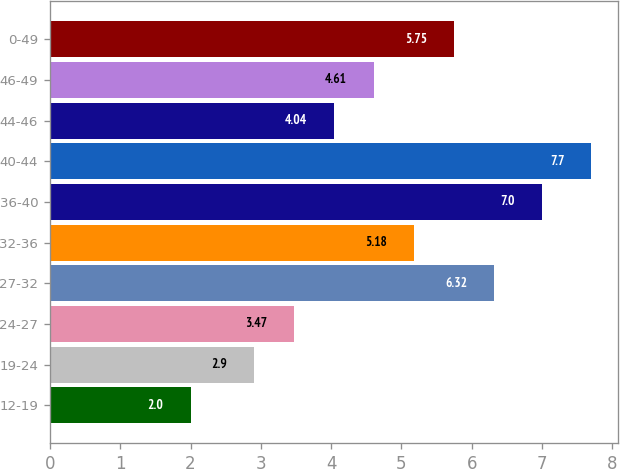<chart> <loc_0><loc_0><loc_500><loc_500><bar_chart><fcel>12-19<fcel>19-24<fcel>24-27<fcel>27-32<fcel>32-36<fcel>36-40<fcel>40-44<fcel>44-46<fcel>46-49<fcel>0-49<nl><fcel>2<fcel>2.9<fcel>3.47<fcel>6.32<fcel>5.18<fcel>7<fcel>7.7<fcel>4.04<fcel>4.61<fcel>5.75<nl></chart> 